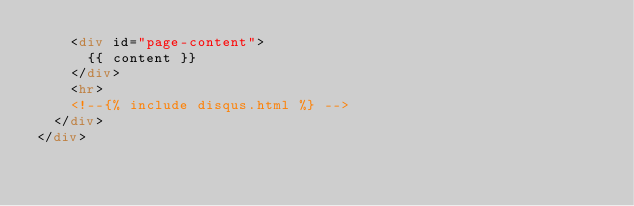<code> <loc_0><loc_0><loc_500><loc_500><_HTML_>    <div id="page-content">
      {{ content }}
    </div>
    <hr>
    <!--{% include disqus.html %} -->
  </div>
</div>
</code> 